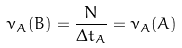<formula> <loc_0><loc_0><loc_500><loc_500>\nu _ { A } ( B ) = \frac { N } { \Delta t _ { A } } = \nu _ { A } ( A )</formula> 